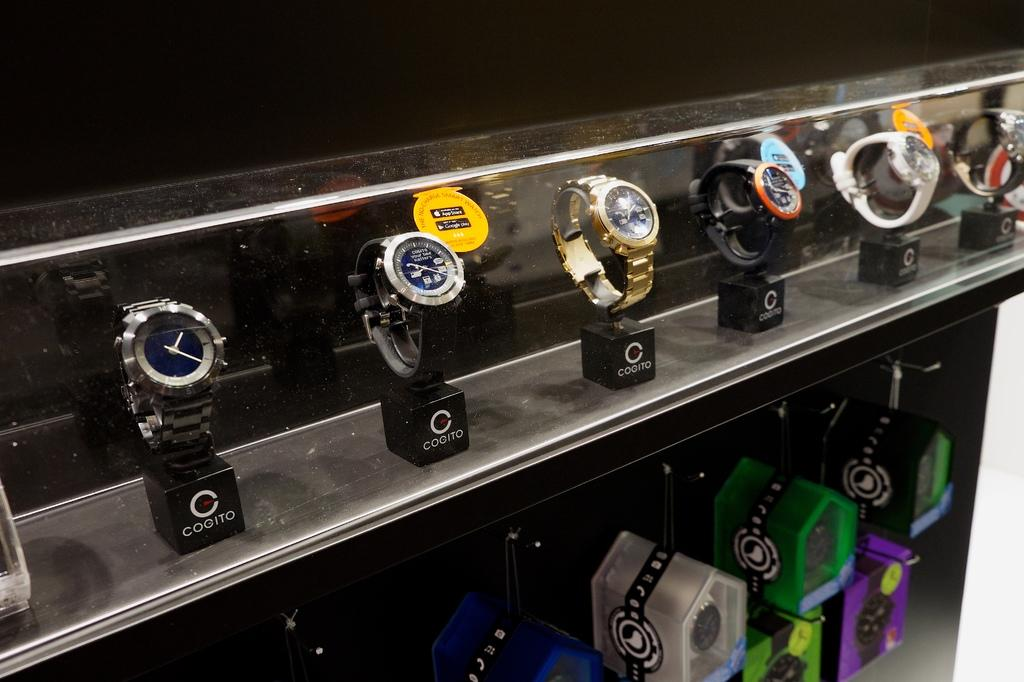What objects are placed in a rack in the image? There are watches placed in a rack in the image. What can be seen on the right side of the image? There are boxes on the right side of the image. Where can the toothpaste be found in the image? There is no toothpaste present in the image. What type of unit is used to measure the watches in the image? The image does not show any units for measuring the watches. 